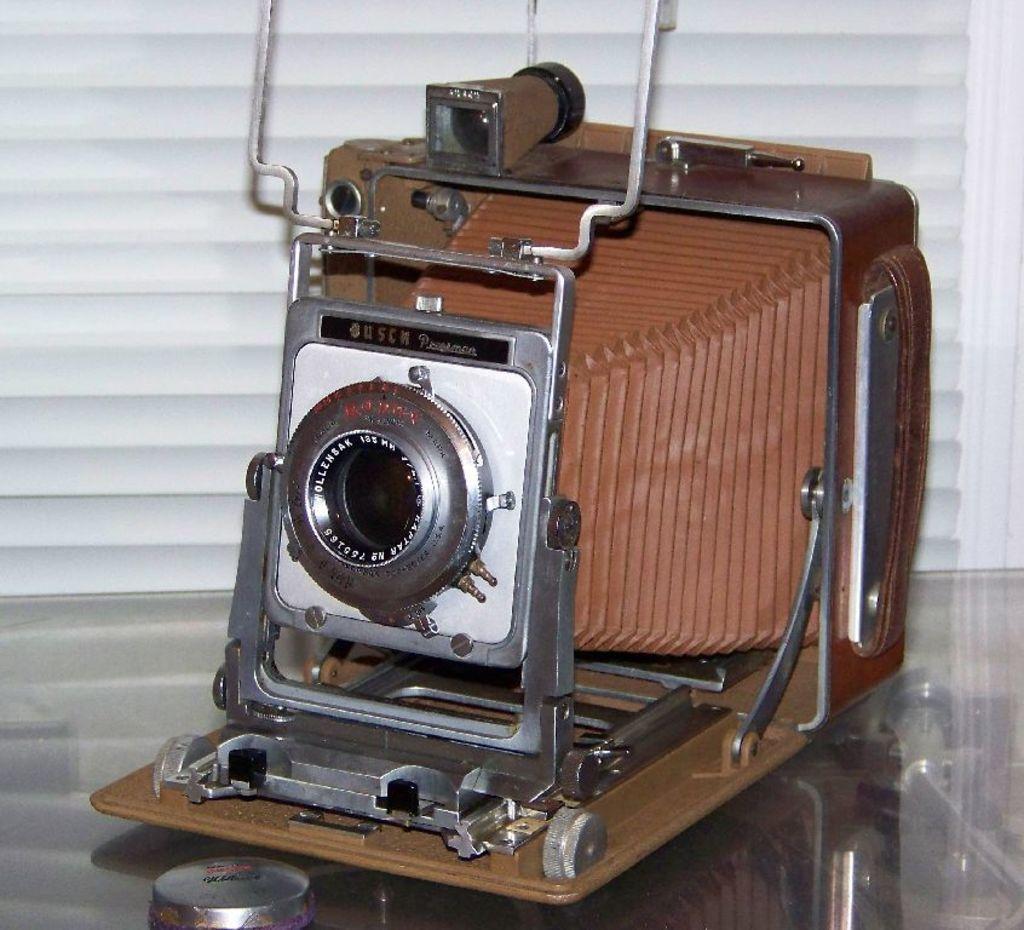Describe this image in one or two sentences. In this picture we can see a press camera on the transparent glass. Behind the press camera, it looks like a wall. 